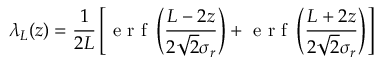Convert formula to latex. <formula><loc_0><loc_0><loc_500><loc_500>\lambda _ { L } ( z ) = \frac { 1 } { 2 L } \left [ e r f \left ( \frac { L - 2 z } { 2 \sqrt { 2 } \sigma _ { r } } \right ) + e r f \left ( \frac { L + 2 z } { 2 \sqrt { 2 } \sigma _ { r } } \right ) \right ]</formula> 